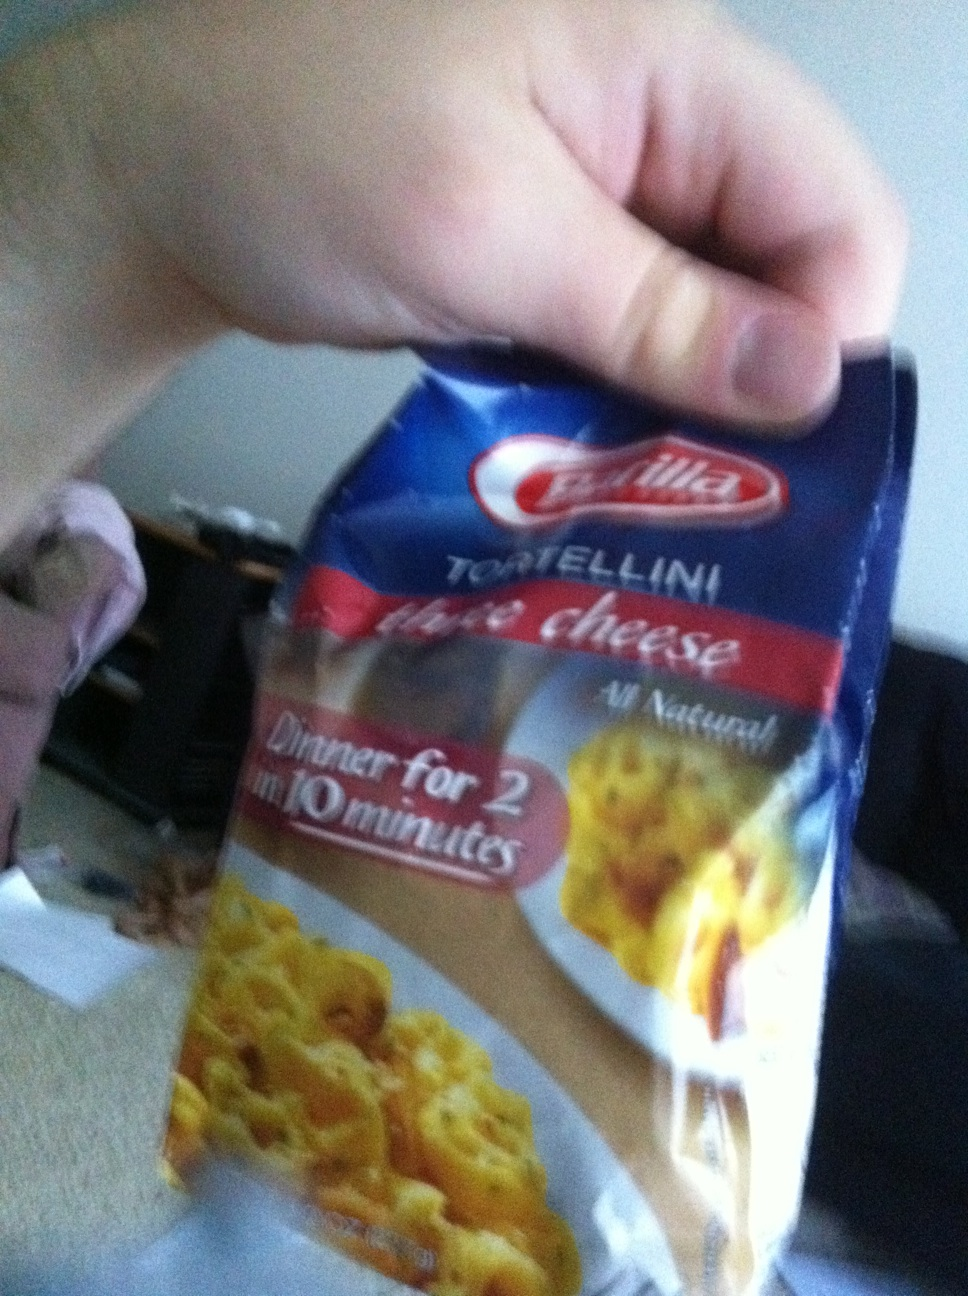What is this food package? This is a package of Barilla three cheese tortellini. It's an all-natural pasta dish that serves two people and can be ready in just 10 minutes. Perfect for a quick and delicious dinner. 